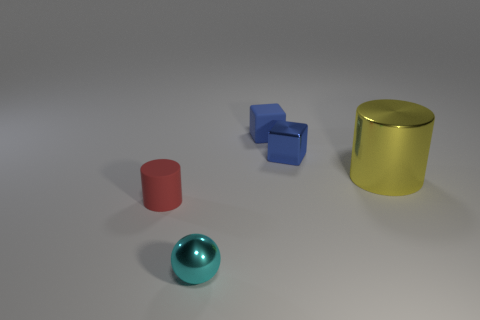What number of objects are either large yellow metal cylinders or tiny rubber objects?
Your response must be concise. 3. What number of red rubber things are the same size as the yellow cylinder?
Make the answer very short. 0. What shape is the metallic thing that is behind the cylinder behind the red thing?
Provide a short and direct response. Cube. Is the number of cyan metal things less than the number of large green shiny cylinders?
Keep it short and to the point. No. There is a matte object in front of the big yellow cylinder; what is its color?
Offer a terse response. Red. What is the material of the thing that is both behind the yellow cylinder and to the left of the tiny metal block?
Give a very brief answer. Rubber. What shape is the small cyan object that is the same material as the yellow cylinder?
Your answer should be compact. Sphere. What number of blue shiny objects are to the right of the blue cube to the left of the metallic block?
Provide a short and direct response. 1. What number of small things are in front of the small red cylinder and behind the small cyan object?
Provide a short and direct response. 0. How many other objects are the same material as the cyan object?
Provide a succinct answer. 2. 